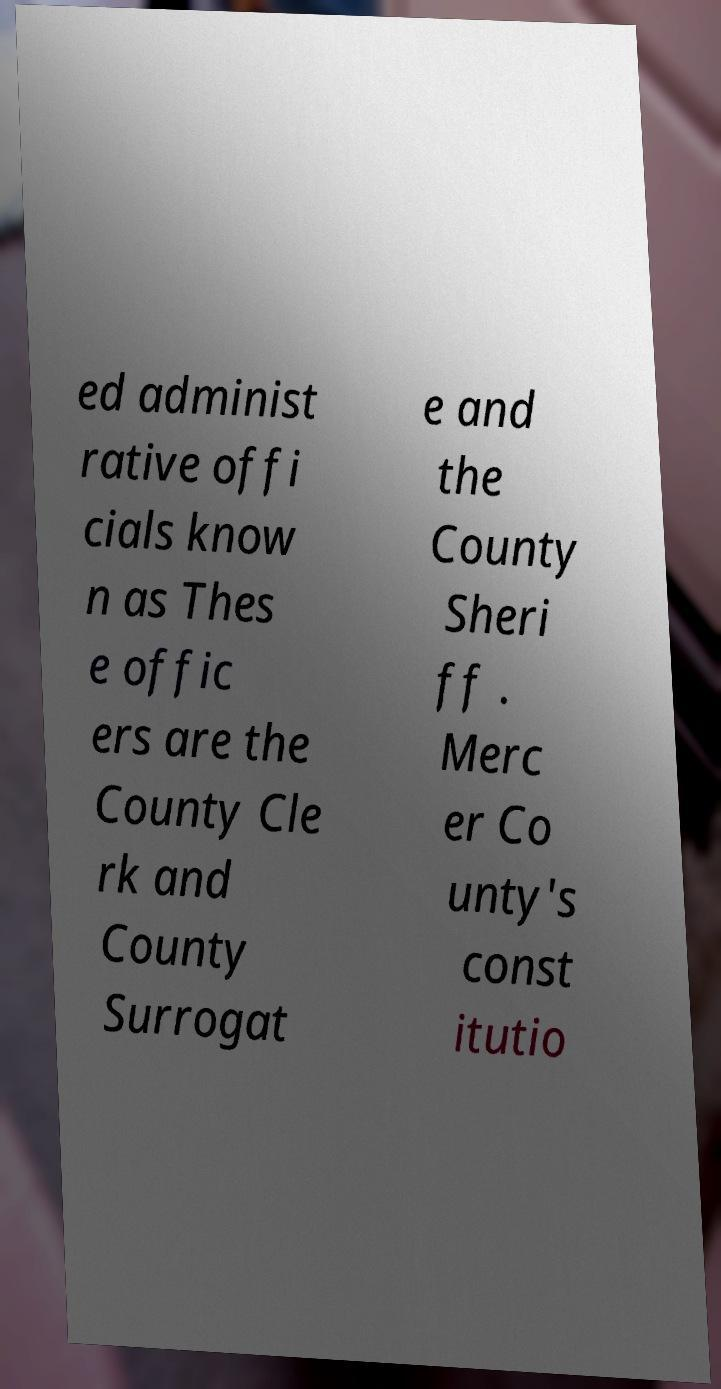Please identify and transcribe the text found in this image. ed administ rative offi cials know n as Thes e offic ers are the County Cle rk and County Surrogat e and the County Sheri ff . Merc er Co unty's const itutio 